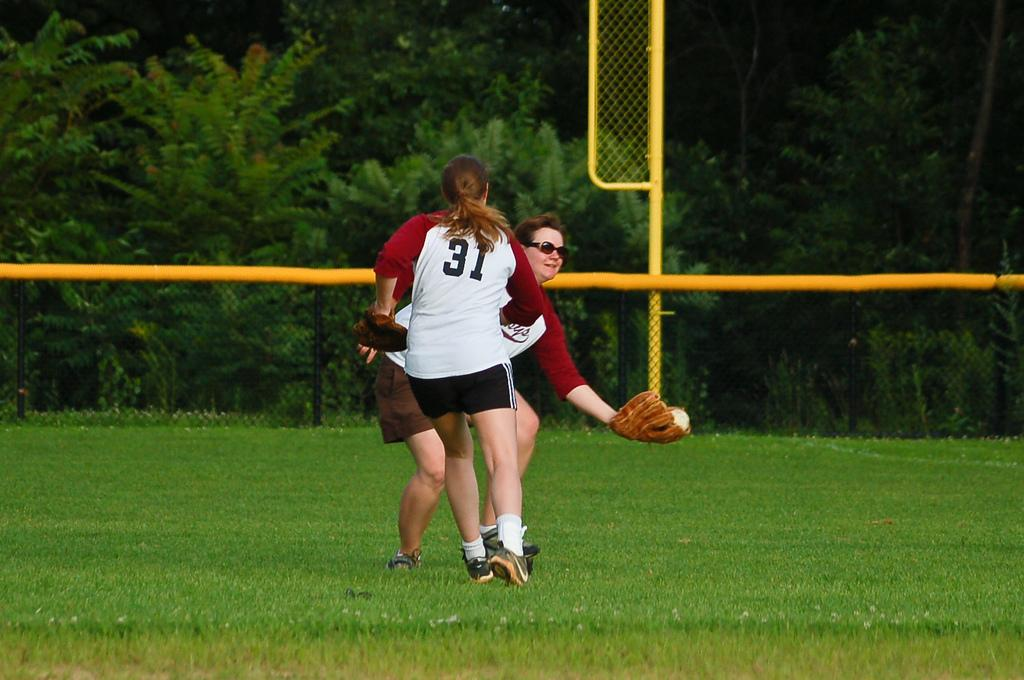<image>
Describe the image concisely. 2 women in maroon and white jerseys play softball, number 31 runs toward the lady catching the ball. 